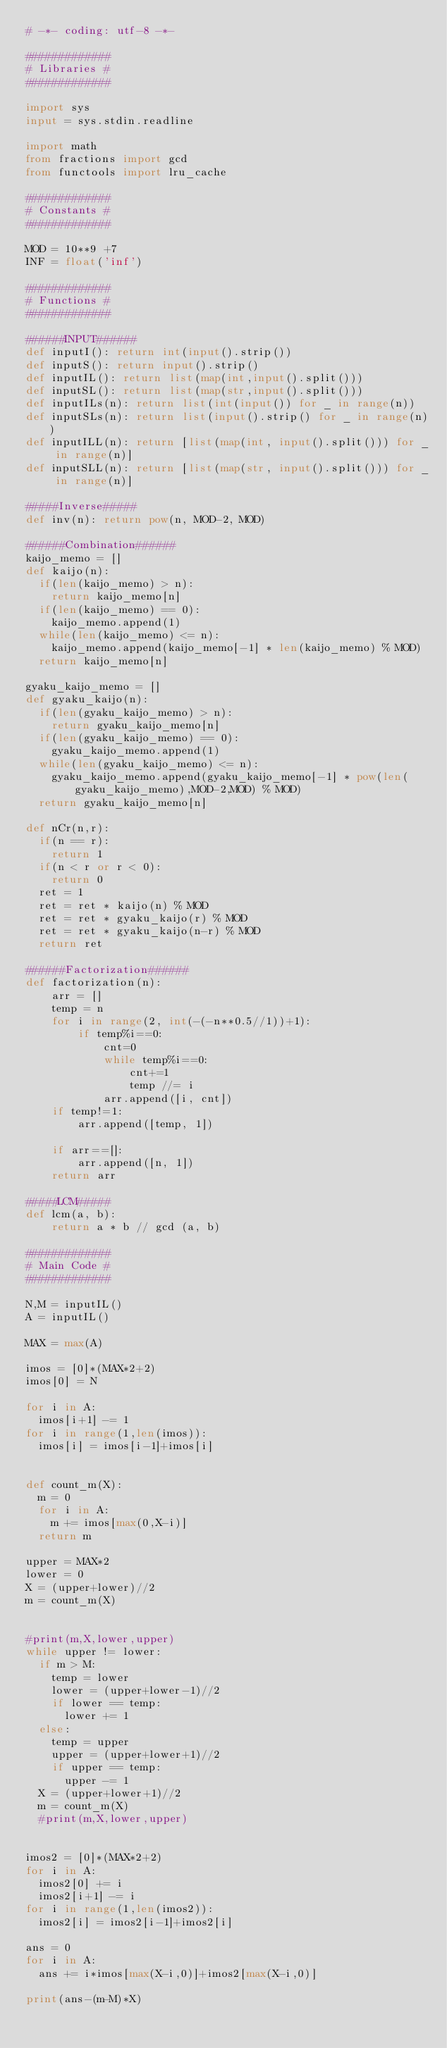Convert code to text. <code><loc_0><loc_0><loc_500><loc_500><_Python_># -*- coding: utf-8 -*-

#############
# Libraries #
#############

import sys
input = sys.stdin.readline

import math
from fractions import gcd
from functools import lru_cache

#############
# Constants #
#############

MOD = 10**9 +7
INF = float('inf')

#############
# Functions #
#############

######INPUT######
def inputI(): return int(input().strip())
def inputS(): return input().strip()
def inputIL(): return list(map(int,input().split()))
def inputSL(): return list(map(str,input().split()))
def inputILs(n): return list(int(input()) for _ in range(n))
def inputSLs(n): return list(input().strip() for _ in range(n))
def inputILL(n): return [list(map(int, input().split())) for _ in range(n)]
def inputSLL(n): return [list(map(str, input().split())) for _ in range(n)]

#####Inverse#####
def inv(n): return pow(n, MOD-2, MOD)

######Combination######
kaijo_memo = []
def kaijo(n):
  if(len(kaijo_memo) > n):
    return kaijo_memo[n]
  if(len(kaijo_memo) == 0):
    kaijo_memo.append(1)
  while(len(kaijo_memo) <= n):
    kaijo_memo.append(kaijo_memo[-1] * len(kaijo_memo) % MOD)
  return kaijo_memo[n]

gyaku_kaijo_memo = []
def gyaku_kaijo(n):
  if(len(gyaku_kaijo_memo) > n):
    return gyaku_kaijo_memo[n]
  if(len(gyaku_kaijo_memo) == 0):
    gyaku_kaijo_memo.append(1)
  while(len(gyaku_kaijo_memo) <= n):
    gyaku_kaijo_memo.append(gyaku_kaijo_memo[-1] * pow(len(gyaku_kaijo_memo),MOD-2,MOD) % MOD)
  return gyaku_kaijo_memo[n]

def nCr(n,r):
  if(n == r):
    return 1
  if(n < r or r < 0):
    return 0
  ret = 1
  ret = ret * kaijo(n) % MOD
  ret = ret * gyaku_kaijo(r) % MOD
  ret = ret * gyaku_kaijo(n-r) % MOD
  return ret

######Factorization######
def factorization(n):
    arr = []
    temp = n
    for i in range(2, int(-(-n**0.5//1))+1):
        if temp%i==0:
            cnt=0
            while temp%i==0:
                cnt+=1
                temp //= i
            arr.append([i, cnt])
    if temp!=1:
        arr.append([temp, 1])

    if arr==[]:
        arr.append([n, 1])
    return arr

#####LCM#####
def lcm(a, b):
    return a * b // gcd (a, b)

#############
# Main Code #
#############

N,M = inputIL()
A = inputIL()

MAX = max(A)

imos = [0]*(MAX*2+2)
imos[0] = N

for i in A:
  imos[i+1] -= 1
for i in range(1,len(imos)):
  imos[i] = imos[i-1]+imos[i]


def count_m(X):
  m = 0
  for i in A:
    m += imos[max(0,X-i)]
  return m

upper = MAX*2
lower = 0
X = (upper+lower)//2
m = count_m(X)


#print(m,X,lower,upper)
while upper != lower:
  if m > M:
    temp = lower
    lower = (upper+lower-1)//2
    if lower == temp:
      lower += 1
  else:
    temp = upper
    upper = (upper+lower+1)//2
    if upper == temp:
      upper -= 1
  X = (upper+lower+1)//2
  m = count_m(X)
  #print(m,X,lower,upper)

  
imos2 = [0]*(MAX*2+2)
for i in A:
  imos2[0] += i
  imos2[i+1] -= i
for i in range(1,len(imos2)):
  imos2[i] = imos2[i-1]+imos2[i]
  
ans = 0
for i in A:
  ans += i*imos[max(X-i,0)]+imos2[max(X-i,0)]
  
print(ans-(m-M)*X)
</code> 